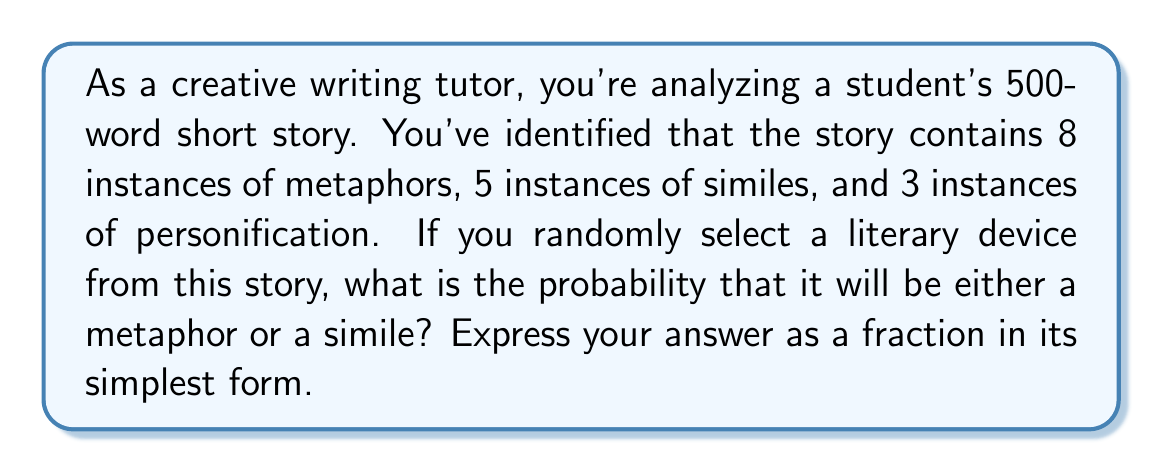Solve this math problem. To solve this problem, we need to follow these steps:

1. Calculate the total number of literary devices in the story:
   $$ \text{Total devices} = \text{Metaphors} + \text{Similes} + \text{Personification} $$
   $$ \text{Total devices} = 8 + 5 + 3 = 16 $$

2. Calculate the number of favorable outcomes (metaphors or similes):
   $$ \text{Favorable outcomes} = \text{Metaphors} + \text{Similes} $$
   $$ \text{Favorable outcomes} = 8 + 5 = 13 $$

3. Calculate the probability using the formula:
   $$ P(\text{Metaphor or Simile}) = \frac{\text{Number of favorable outcomes}}{\text{Total number of possible outcomes}} $$

4. Substitute the values:
   $$ P(\text{Metaphor or Simile}) = \frac{13}{16} $$

5. The fraction $\frac{13}{16}$ is already in its simplest form, as 13 and 16 have no common factors other than 1.

Therefore, the probability of randomly selecting either a metaphor or a simile from the given story is $\frac{13}{16}$.
Answer: $\frac{13}{16}$ 